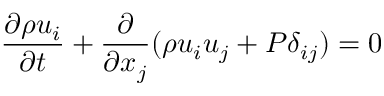Convert formula to latex. <formula><loc_0><loc_0><loc_500><loc_500>\frac { \partial \rho u _ { i } } { \partial t } + \frac { \partial } { \partial x _ { j } } ( \rho u _ { i } u _ { j } + P \delta _ { i j } ) = 0</formula> 